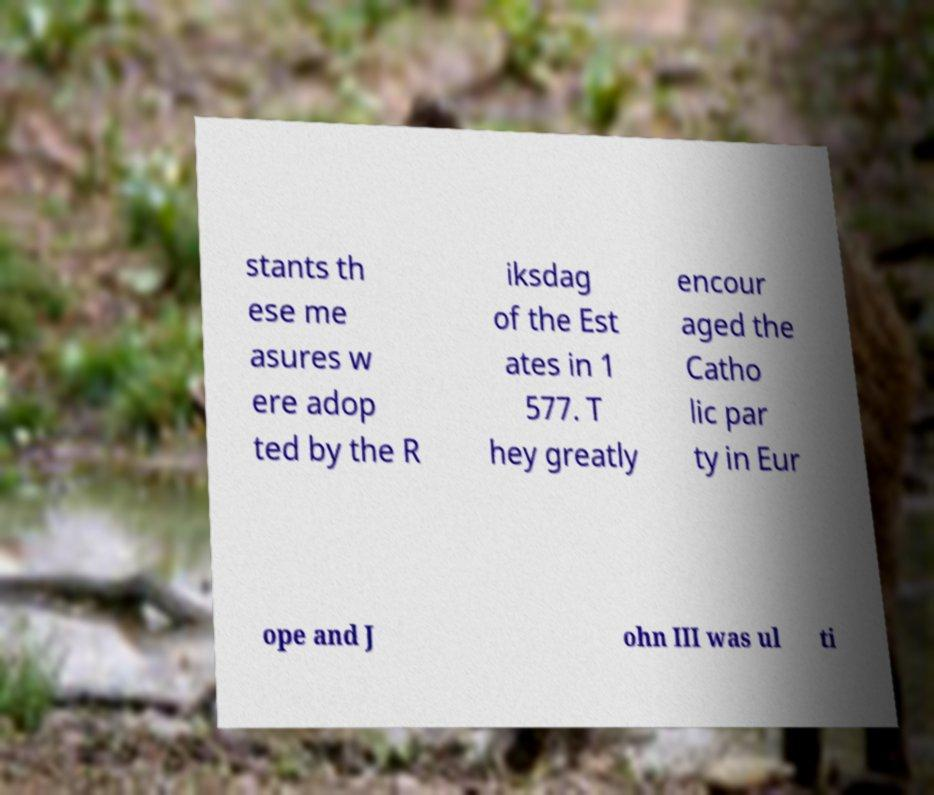Could you assist in decoding the text presented in this image and type it out clearly? stants th ese me asures w ere adop ted by the R iksdag of the Est ates in 1 577. T hey greatly encour aged the Catho lic par ty in Eur ope and J ohn III was ul ti 